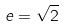<formula> <loc_0><loc_0><loc_500><loc_500>e = { \sqrt { 2 } }</formula> 